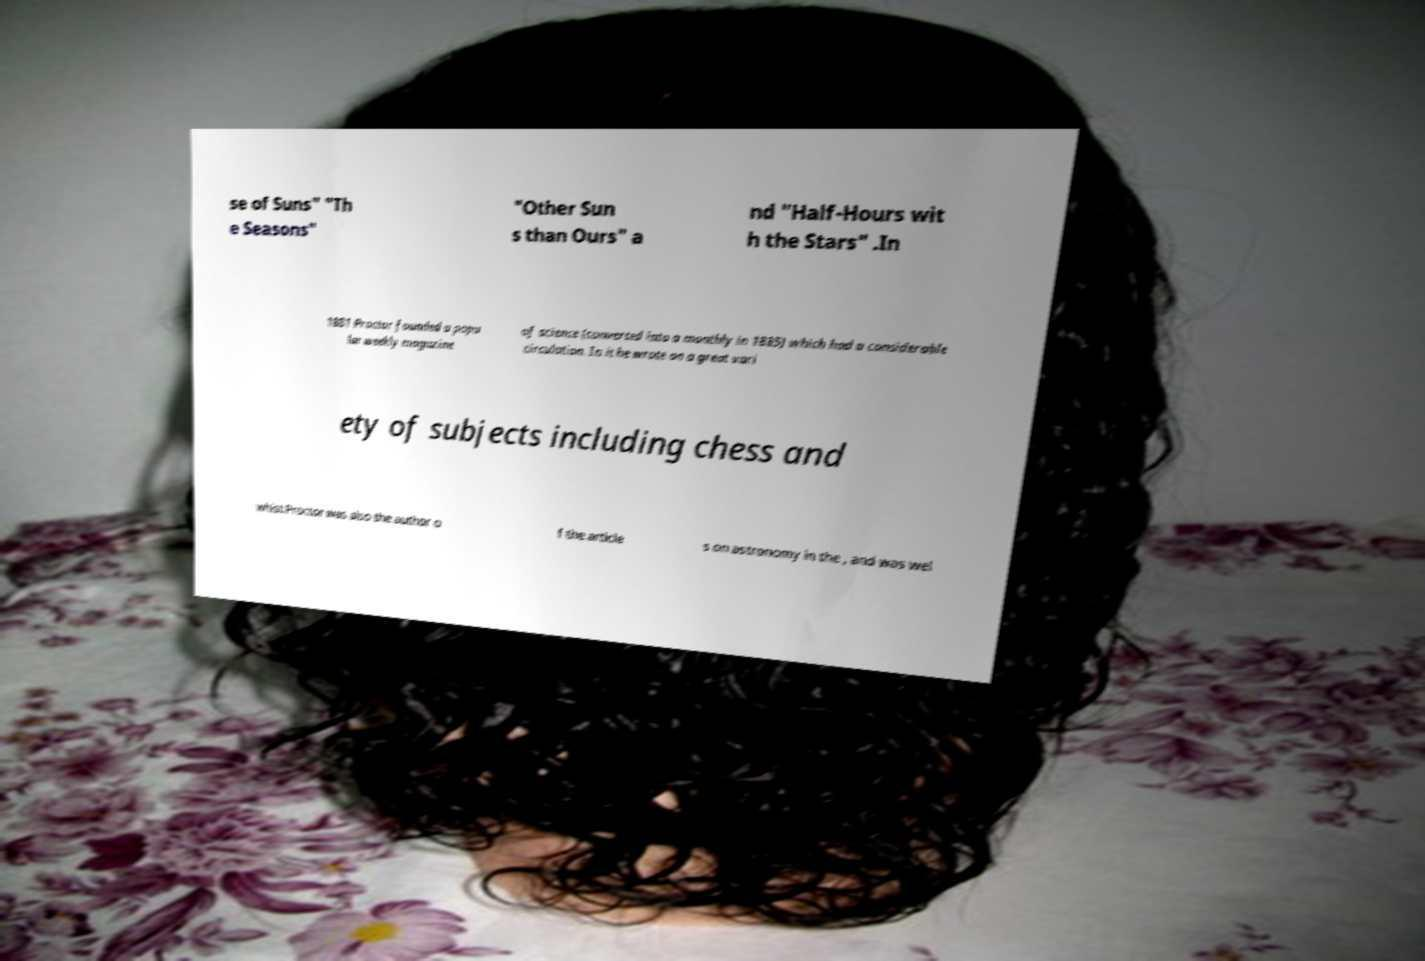Please read and relay the text visible in this image. What does it say? se of Suns" "Th e Seasons" "Other Sun s than Ours" a nd "Half-Hours wit h the Stars" .In 1881 Proctor founded a popu lar weekly magazine of science (converted into a monthly in 1885) which had a considerable circulation. In it he wrote on a great vari ety of subjects including chess and whist.Proctor was also the author o f the article s on astronomy in the , and was wel 